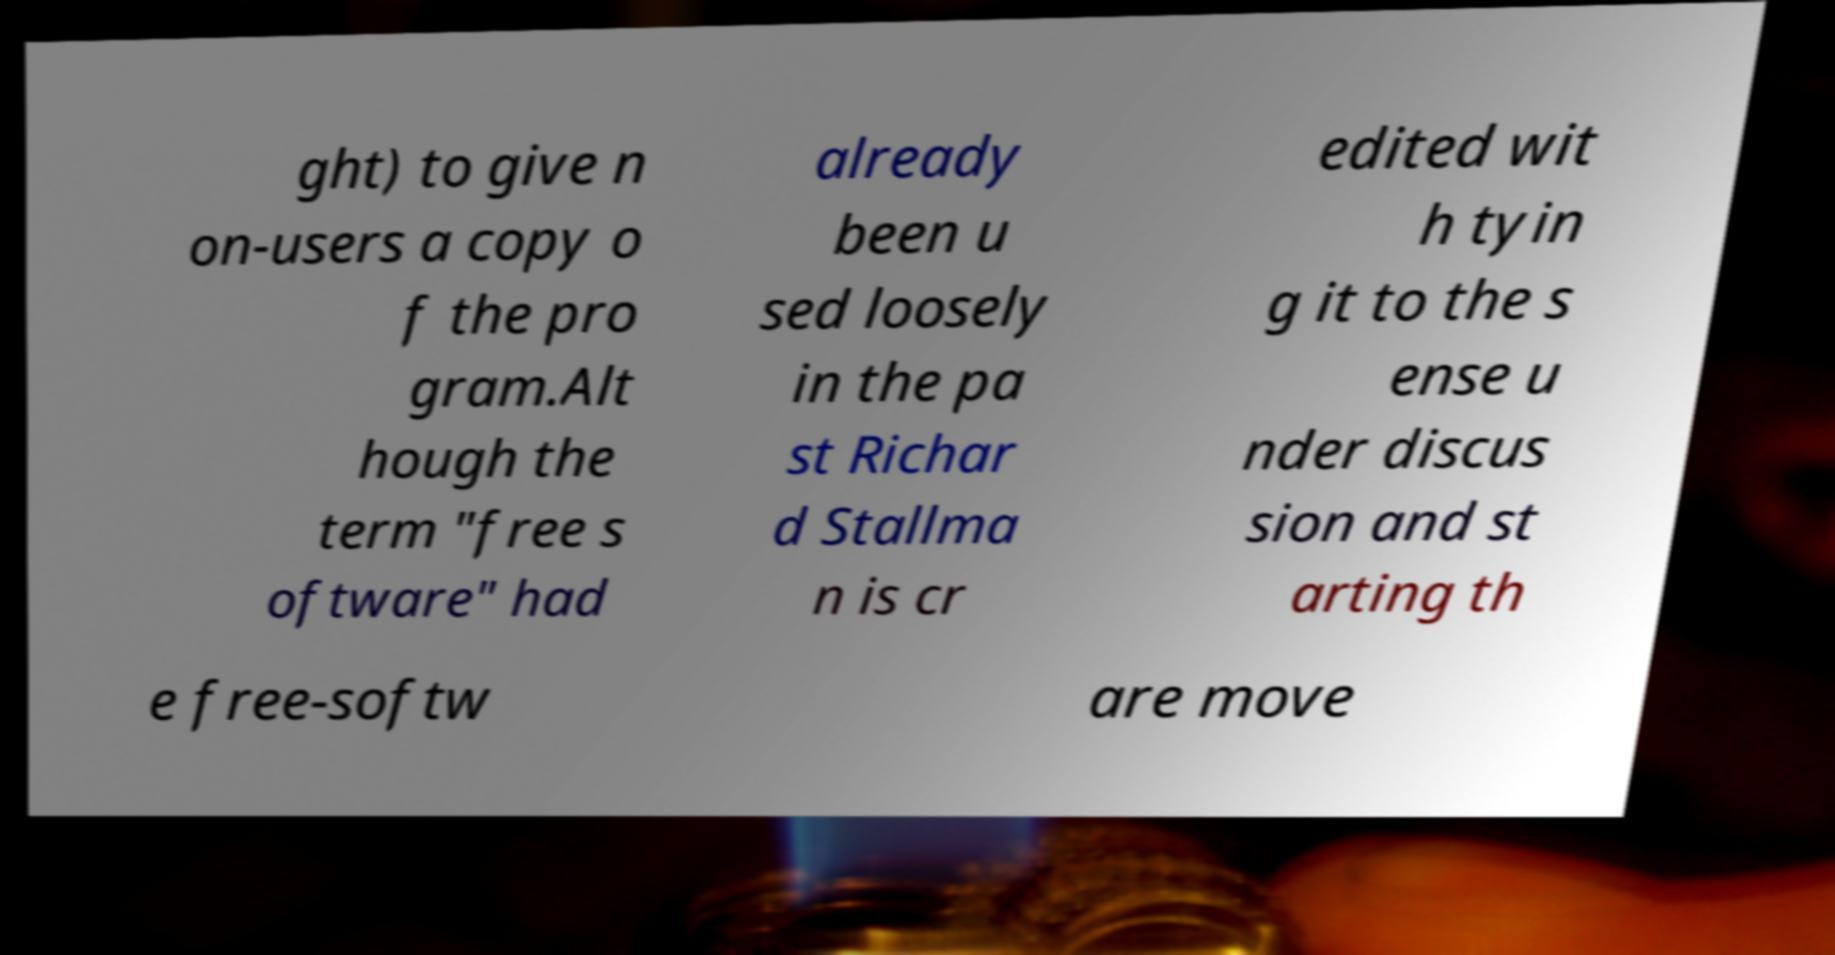Can you accurately transcribe the text from the provided image for me? ght) to give n on-users a copy o f the pro gram.Alt hough the term "free s oftware" had already been u sed loosely in the pa st Richar d Stallma n is cr edited wit h tyin g it to the s ense u nder discus sion and st arting th e free-softw are move 